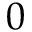Convert formula to latex. <formula><loc_0><loc_0><loc_500><loc_500>0</formula> 